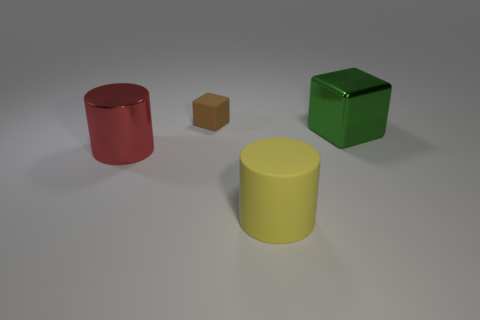Add 4 big red metal balls. How many objects exist? 8 Add 2 big green metal cubes. How many big green metal cubes are left? 3 Add 2 big cylinders. How many big cylinders exist? 4 Subtract 0 gray blocks. How many objects are left? 4 Subtract all gray cylinders. Subtract all matte objects. How many objects are left? 2 